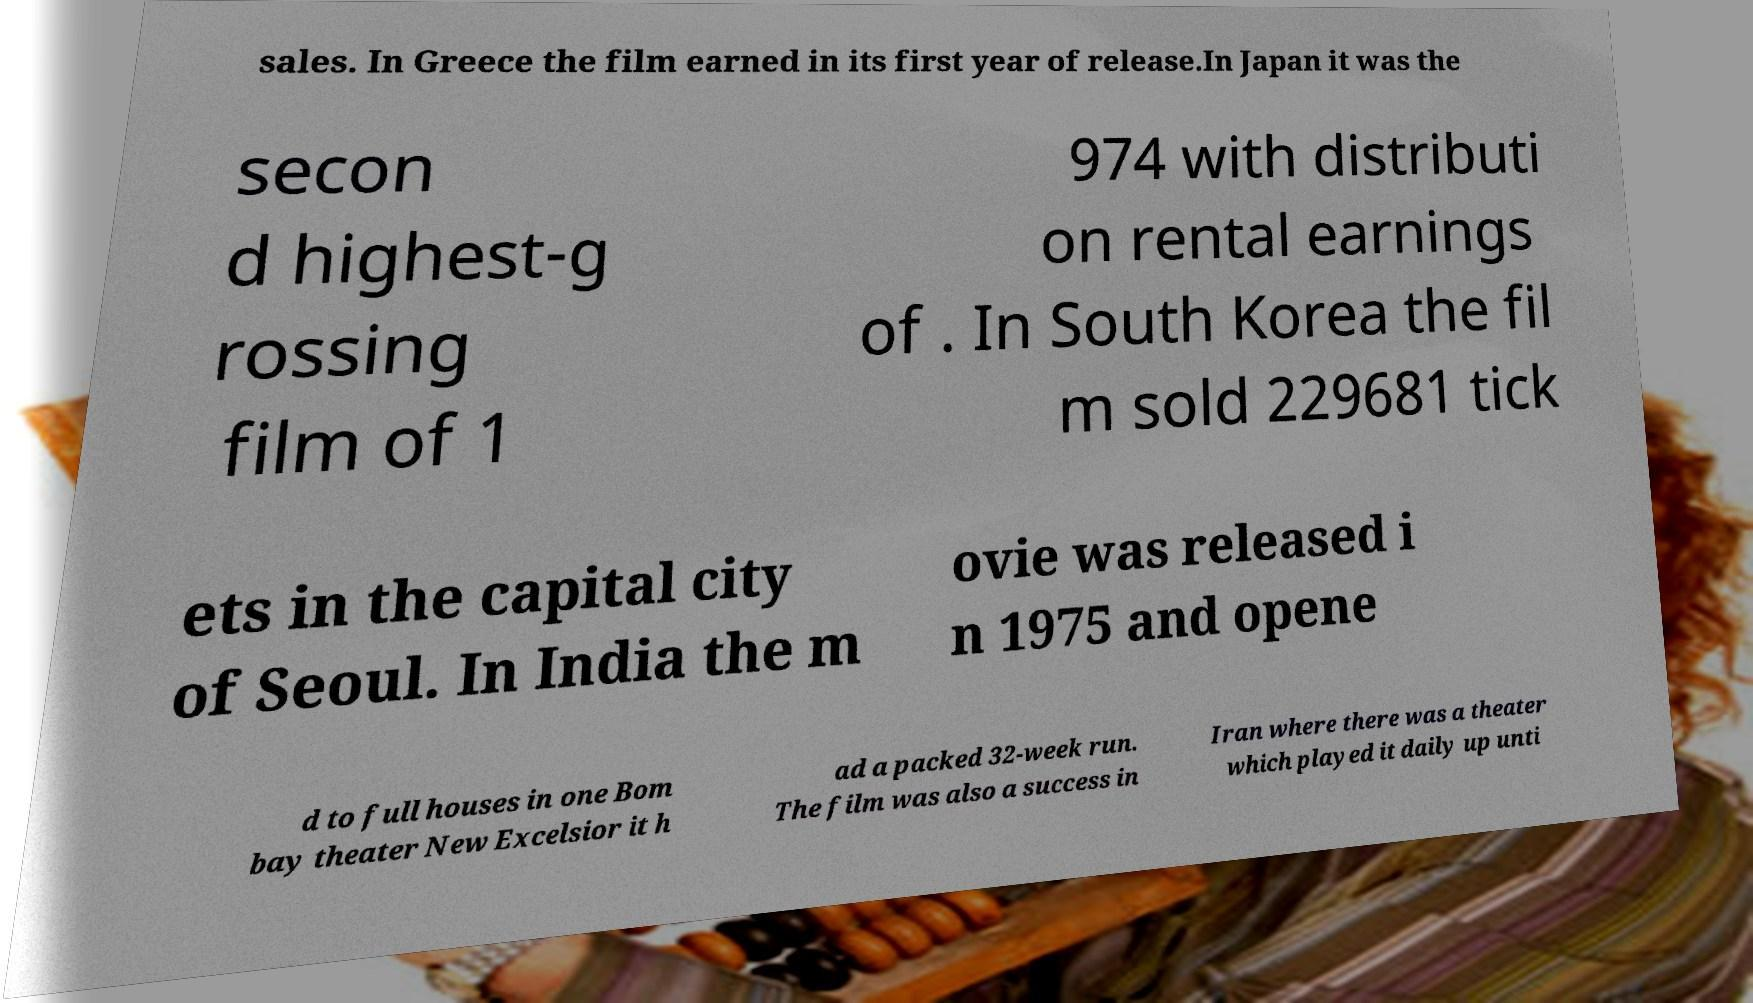Can you accurately transcribe the text from the provided image for me? sales. In Greece the film earned in its first year of release.In Japan it was the secon d highest-g rossing film of 1 974 with distributi on rental earnings of . In South Korea the fil m sold 229681 tick ets in the capital city of Seoul. In India the m ovie was released i n 1975 and opene d to full houses in one Bom bay theater New Excelsior it h ad a packed 32-week run. The film was also a success in Iran where there was a theater which played it daily up unti 